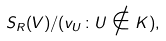Convert formula to latex. <formula><loc_0><loc_0><loc_500><loc_500>S _ { R } ( V ) / ( v _ { U } \colon U \notin K ) ,</formula> 